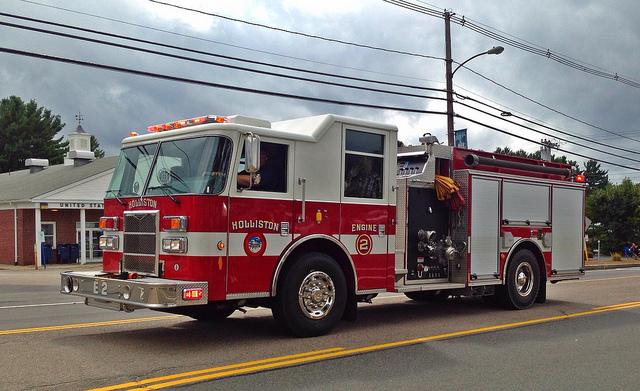Is the truck moving?
Answer briefly. Yes. What is the color of the lines in the road?
Short answer required. Yellow. How many road lanes are visible in the picture?
Concise answer only. 3. 